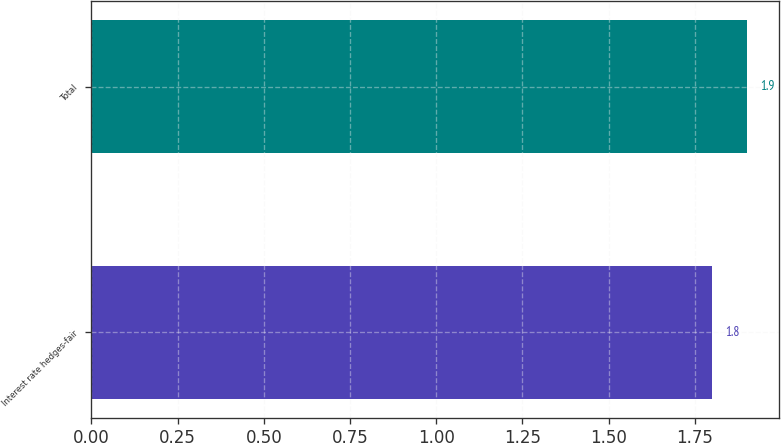<chart> <loc_0><loc_0><loc_500><loc_500><bar_chart><fcel>Interest rate hedges-fair<fcel>Total<nl><fcel>1.8<fcel>1.9<nl></chart> 